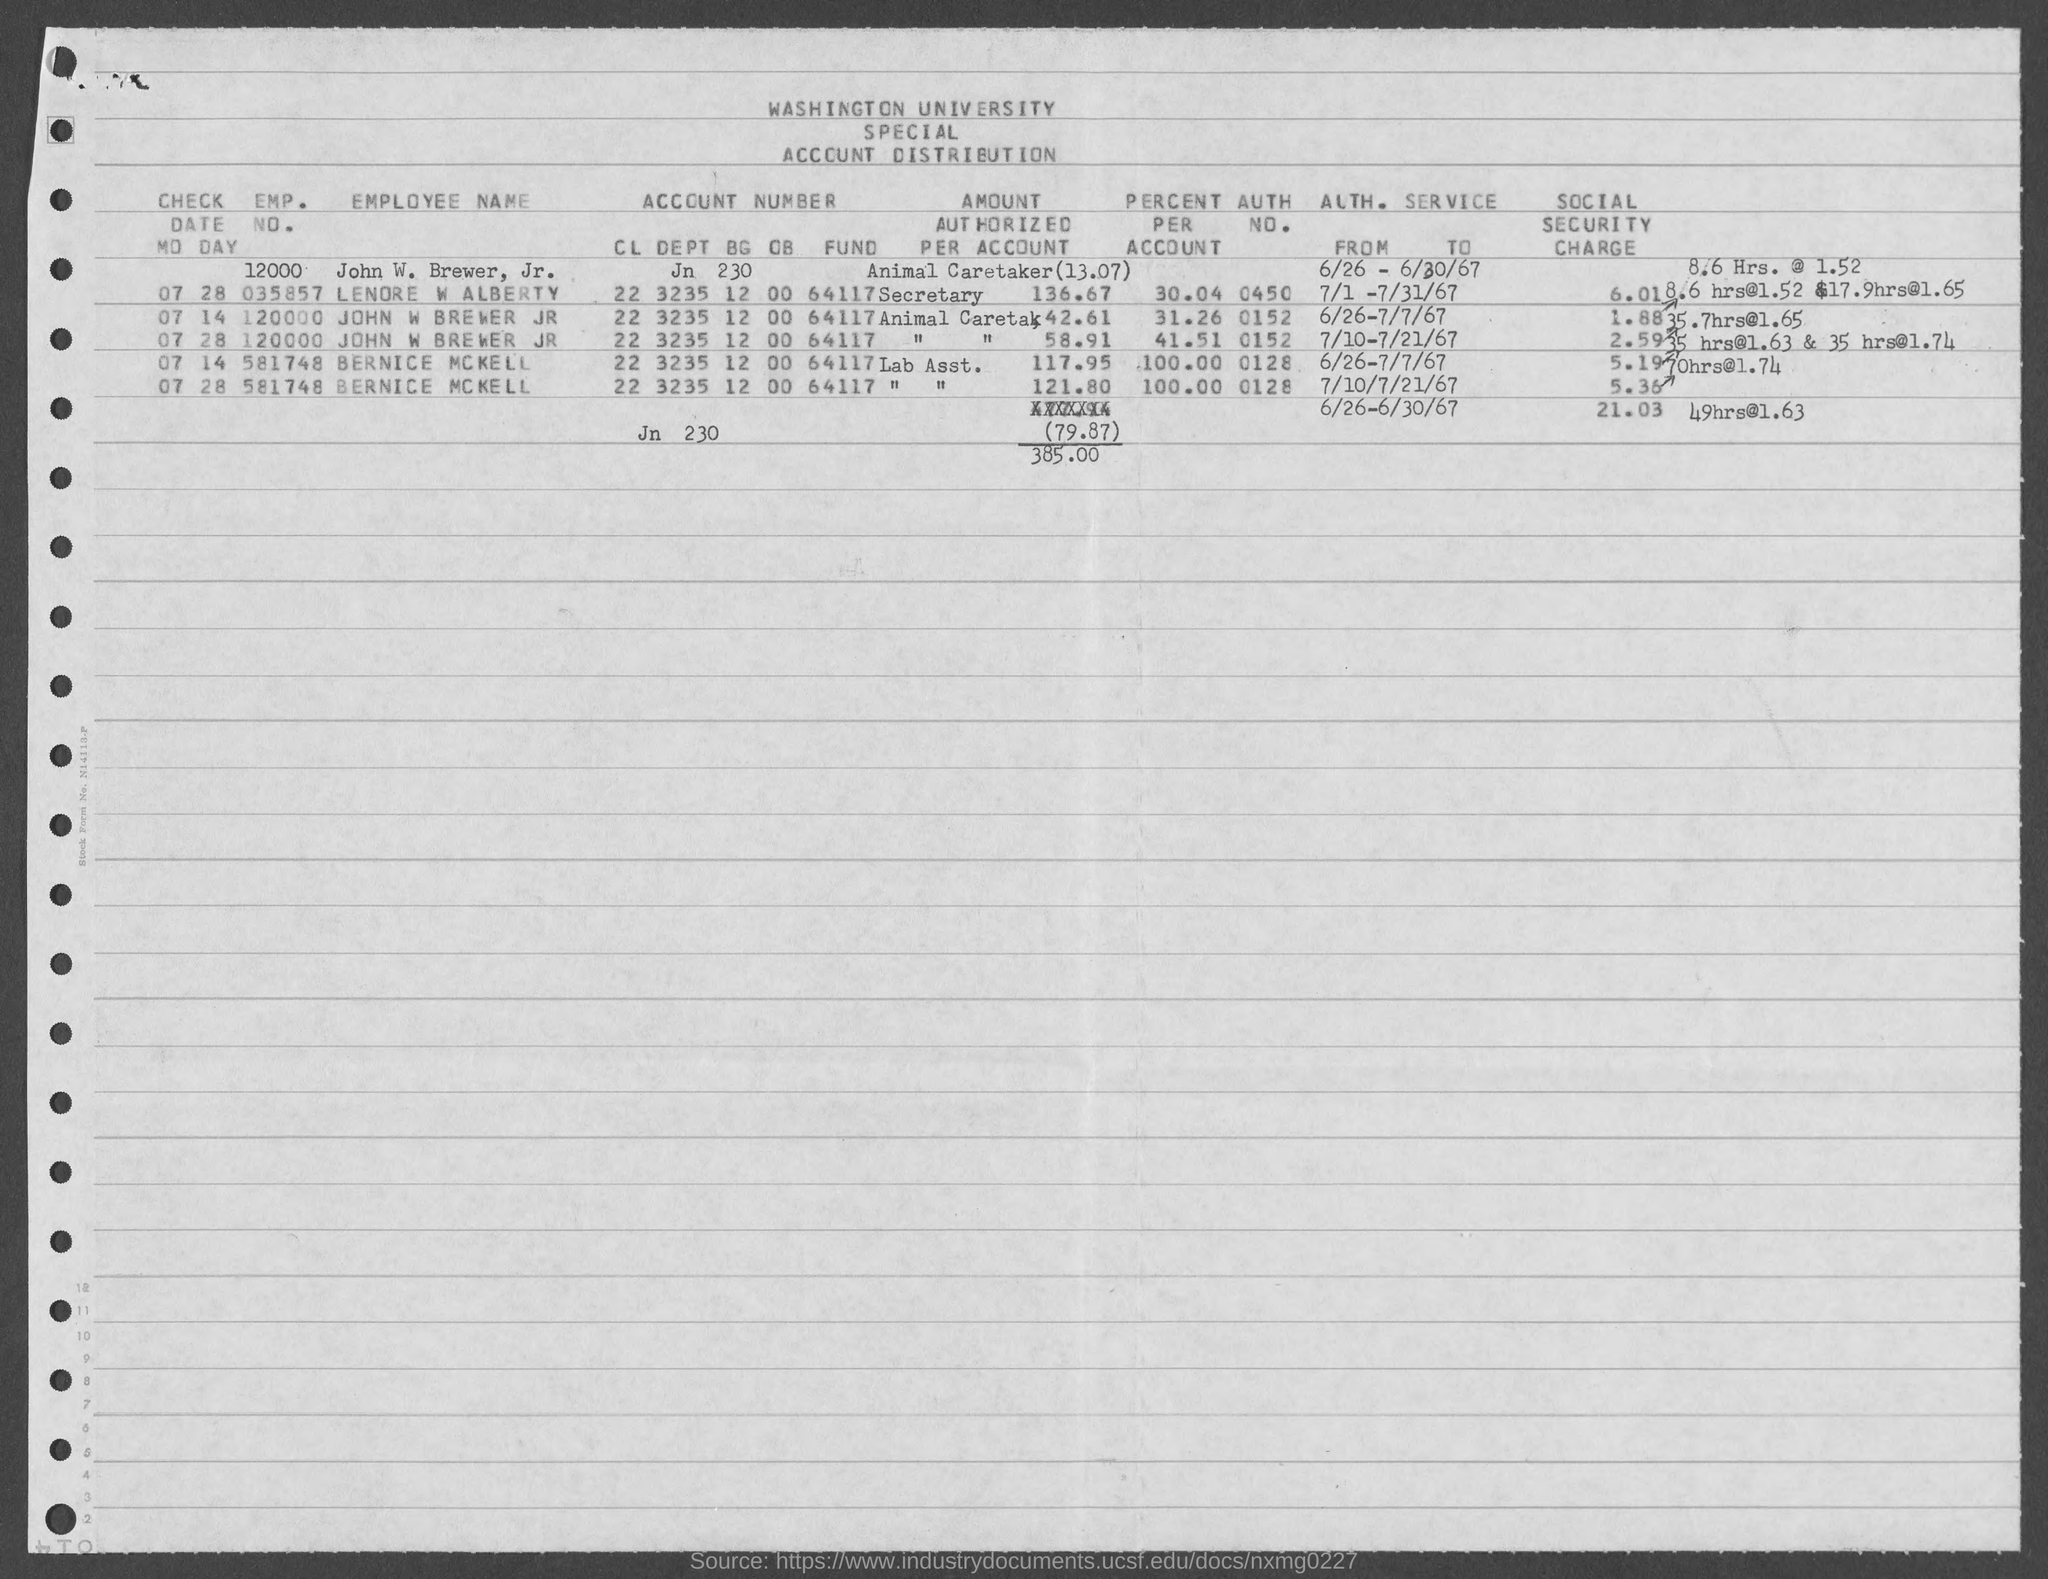Identify some key points in this picture. The given text is a query, asking for the emp. no. of Bernice McKell as mentioned in the form. The value of the percentage of Lenore W Alberty's account for April 2023 is 30.04%. I need to know the authorization number for John W. Brewer Jr. It is 0152. I need to know the authorization number for Bernice McKell. It is 0128. What is the authorization number for Lenore W. Albertly? The number is 0450... 